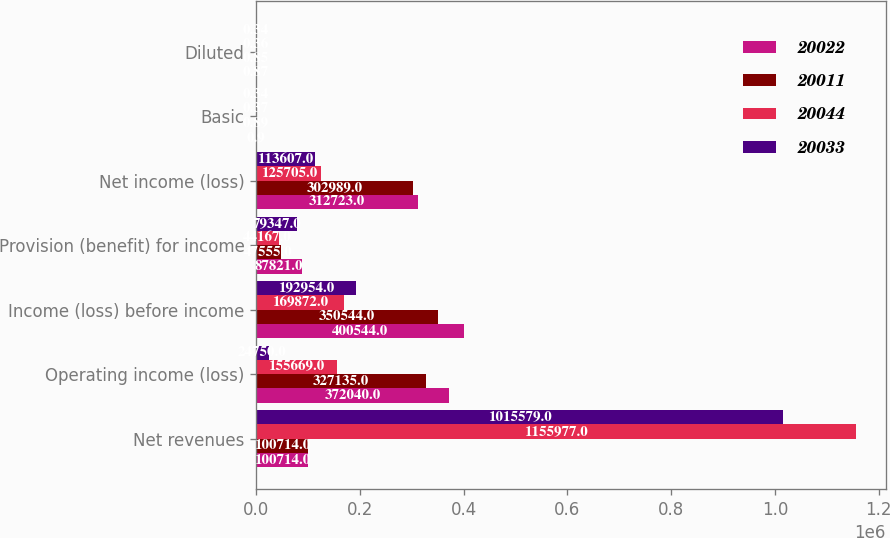Convert chart to OTSL. <chart><loc_0><loc_0><loc_500><loc_500><stacked_bar_chart><ecel><fcel>Net revenues<fcel>Operating income (loss)<fcel>Income (loss) before income<fcel>Provision (benefit) for income<fcel>Net income (loss)<fcel>Basic<fcel>Diluted<nl><fcel>20022<fcel>100714<fcel>372040<fcel>400544<fcel>87821<fcel>312723<fcel>0.9<fcel>0.87<nl><fcel>20011<fcel>100714<fcel>327135<fcel>350544<fcel>47555<fcel>302989<fcel>0.89<fcel>0.85<nl><fcel>20044<fcel>1.15598e+06<fcel>155669<fcel>169872<fcel>44167<fcel>125705<fcel>0.37<fcel>0.36<nl><fcel>20033<fcel>1.01558e+06<fcel>24750<fcel>192954<fcel>79347<fcel>113607<fcel>0.34<fcel>0.34<nl></chart> 